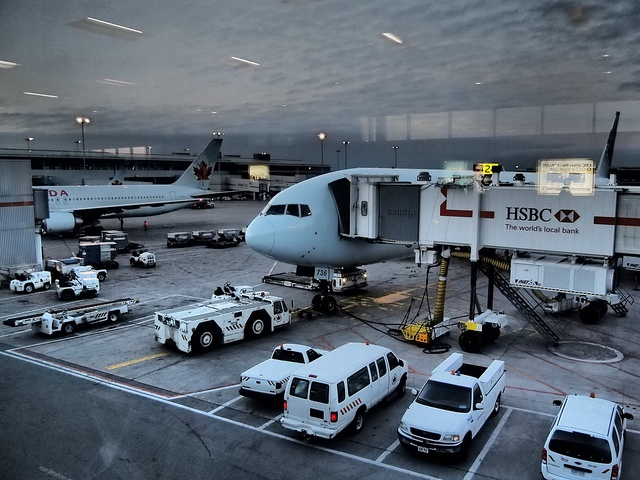Describe the objects in this image and their specific colors. I can see airplane in blue, darkgray, black, and gray tones, car in blue, black, lightblue, and gray tones, truck in blue, black, lightblue, and darkgray tones, airplane in blue, black, gray, and darkgray tones, and car in blue, black, lightblue, and gray tones in this image. 